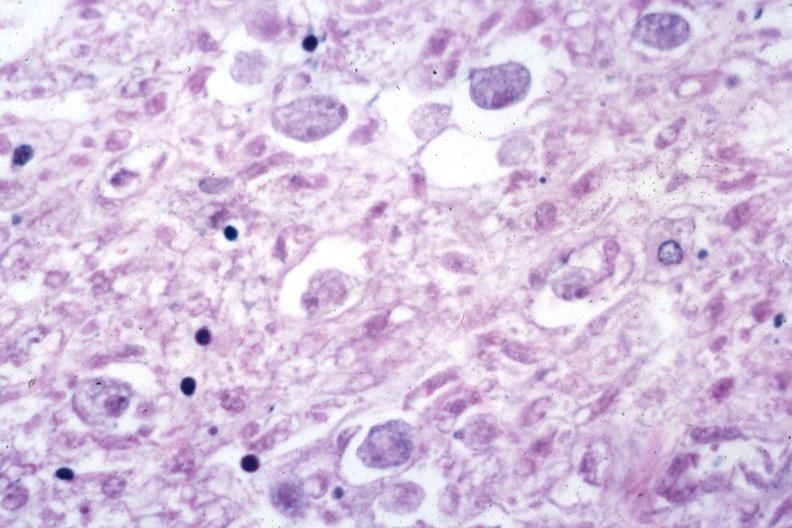s gastrointestinal present?
Answer the question using a single word or phrase. Yes 